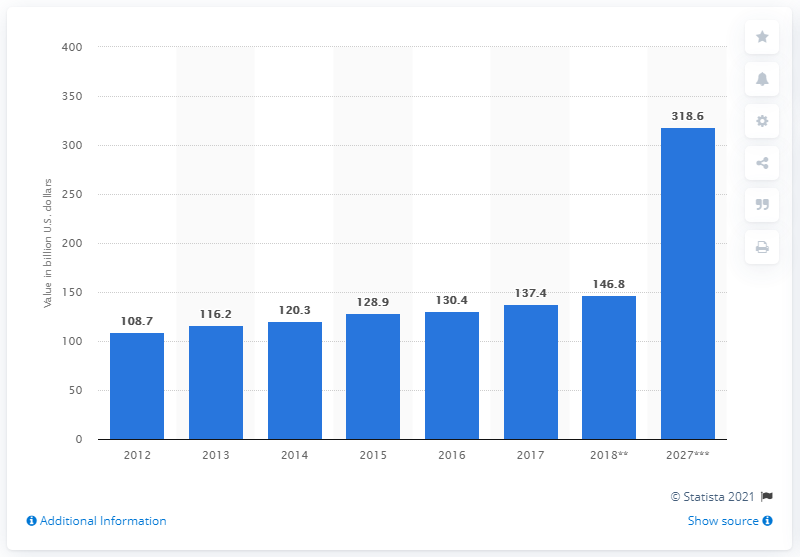Outline some significant characteristics in this image. In 2028, the estimated economic contribution of tourism and travel to the Gross Domestic Product (GDP) of the Gulf Cooperation Council (GCC) was 318.6. 